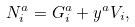<formula> <loc_0><loc_0><loc_500><loc_500>N _ { i } ^ { a } = G _ { i } ^ { a } + y ^ { a } V _ { i } ,</formula> 